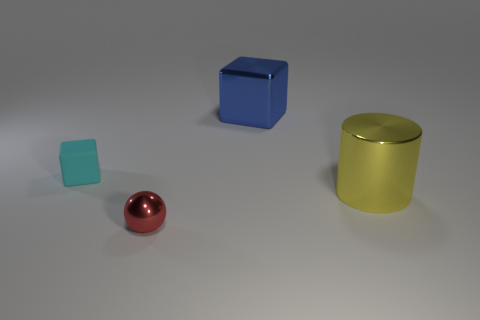Subtract all blue blocks. How many blocks are left? 1 Add 3 large metal blocks. How many objects exist? 7 Subtract all gray cylinders. How many cyan blocks are left? 1 Subtract all spheres. How many objects are left? 3 Subtract 1 cubes. How many cubes are left? 1 Subtract all gray cubes. Subtract all gray balls. How many cubes are left? 2 Subtract all large blue blocks. Subtract all large purple cylinders. How many objects are left? 3 Add 1 big cylinders. How many big cylinders are left? 2 Add 2 tiny blocks. How many tiny blocks exist? 3 Subtract 0 purple spheres. How many objects are left? 4 